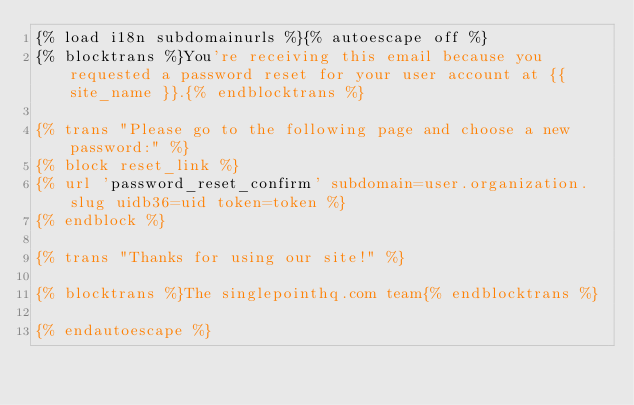Convert code to text. <code><loc_0><loc_0><loc_500><loc_500><_HTML_>{% load i18n subdomainurls %}{% autoescape off %}
{% blocktrans %}You're receiving this email because you requested a password reset for your user account at {{ site_name }}.{% endblocktrans %}

{% trans "Please go to the following page and choose a new password:" %}
{% block reset_link %}
{% url 'password_reset_confirm' subdomain=user.organization.slug uidb36=uid token=token %}
{% endblock %}

{% trans "Thanks for using our site!" %}

{% blocktrans %}The singlepointhq.com team{% endblocktrans %}

{% endautoescape %}
</code> 